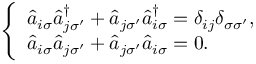Convert formula to latex. <formula><loc_0><loc_0><loc_500><loc_500>\begin{array} { r } { \left \{ \begin{array} { l l } { \hat { a } _ { i \sigma } \hat { a } _ { j \sigma ^ { \prime } } ^ { \dagger } + \hat { a } _ { j \sigma ^ { \prime } } \hat { a } _ { i \sigma } ^ { \dagger } = \delta _ { i j } \delta _ { \sigma { \sigma } ^ { \prime } } , } \\ { \hat { a } _ { i \sigma } \hat { a } _ { j \sigma ^ { \prime } } + \hat { a } _ { j \sigma ^ { \prime } } \hat { a } _ { i \sigma } = 0 . } \end{array} } \end{array}</formula> 